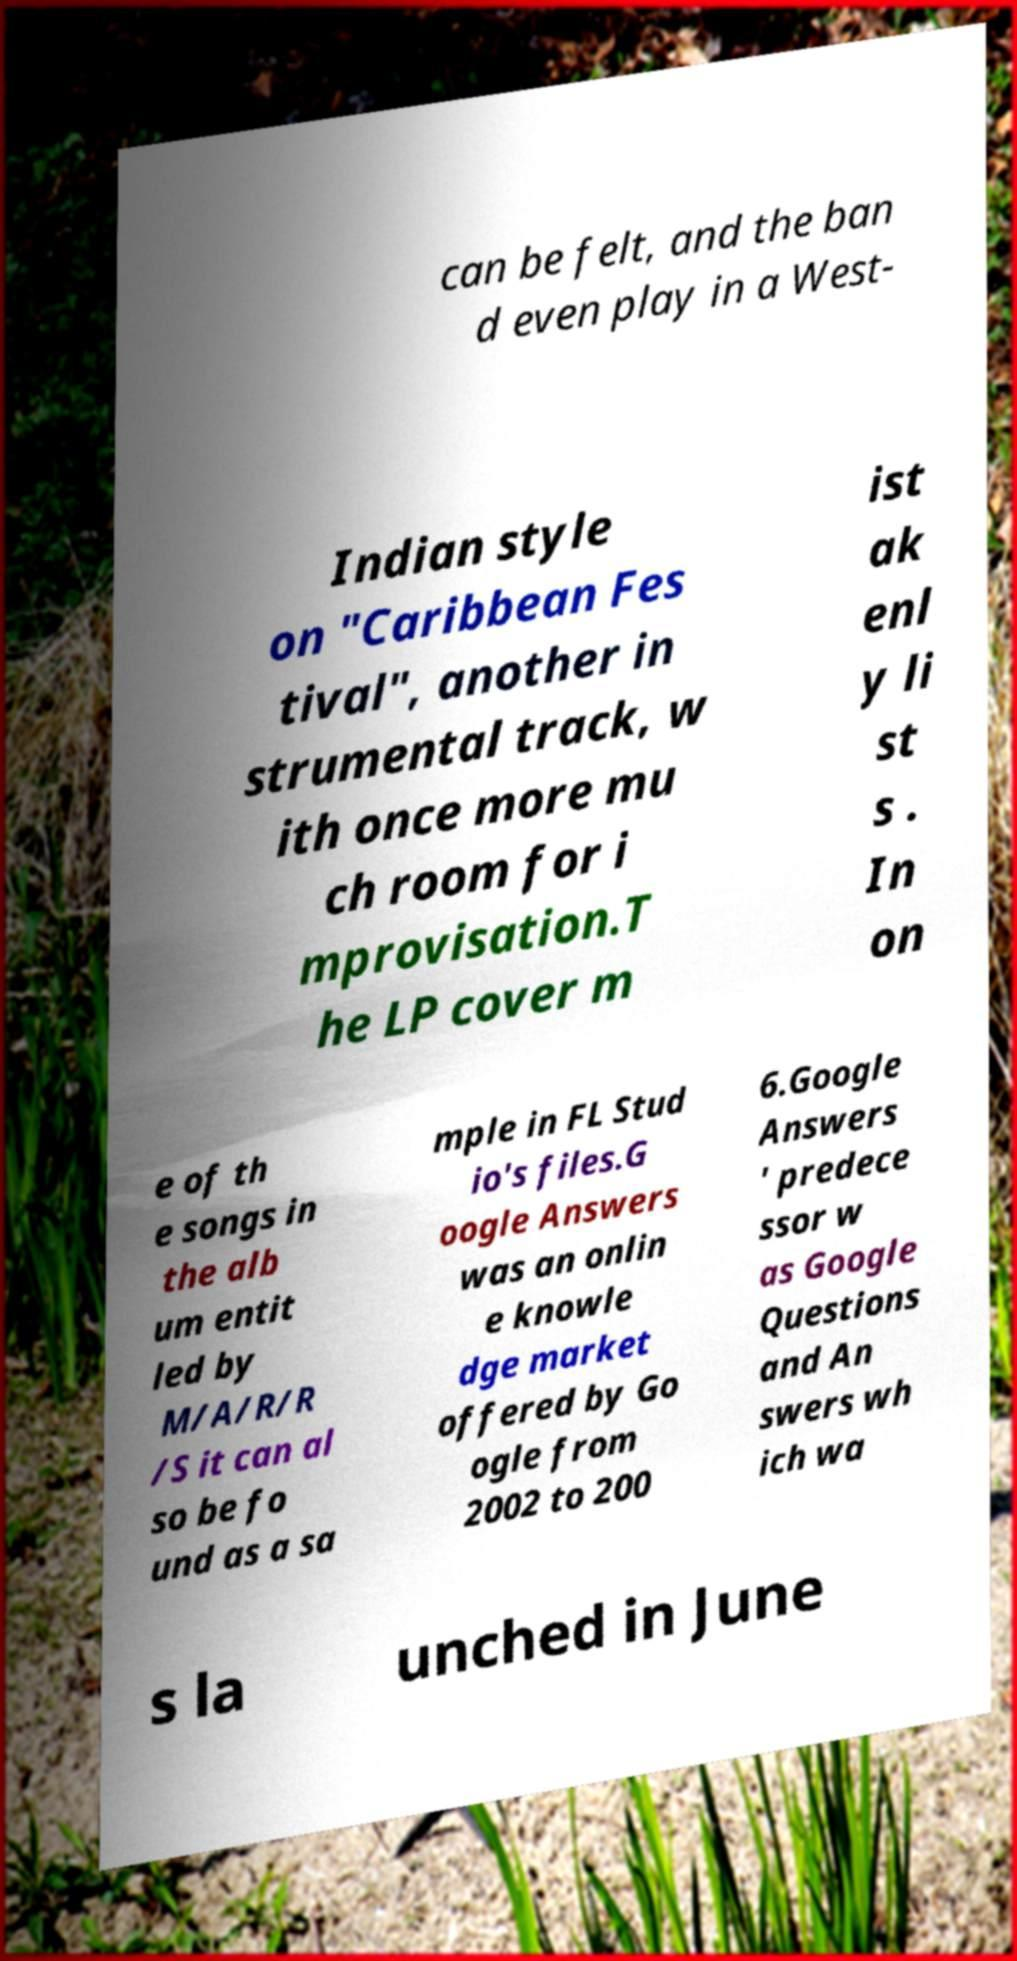For documentation purposes, I need the text within this image transcribed. Could you provide that? can be felt, and the ban d even play in a West- Indian style on "Caribbean Fes tival", another in strumental track, w ith once more mu ch room for i mprovisation.T he LP cover m ist ak enl y li st s . In on e of th e songs in the alb um entit led by M/A/R/R /S it can al so be fo und as a sa mple in FL Stud io's files.G oogle Answers was an onlin e knowle dge market offered by Go ogle from 2002 to 200 6.Google Answers ' predece ssor w as Google Questions and An swers wh ich wa s la unched in June 